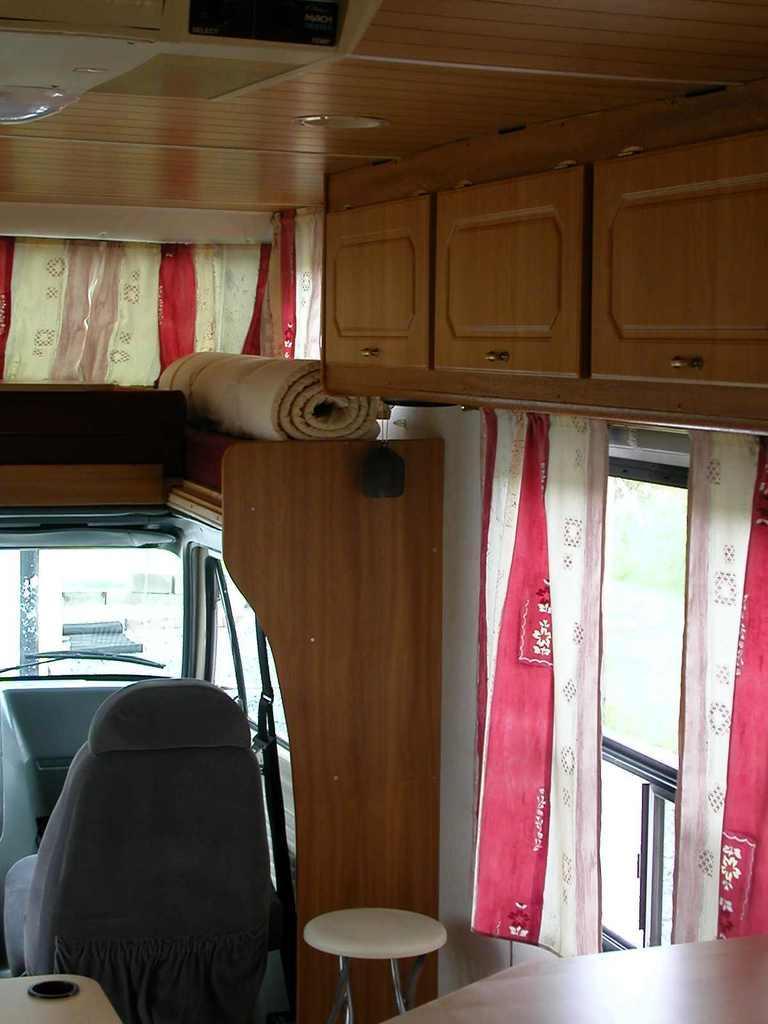Can you describe this image briefly? In this picture we can see a room where on the top we have cupboards and here is a curtain for the window and this is a stool, chair and i think this is a glass and where the sheet is rolled and kept on above the rack. 